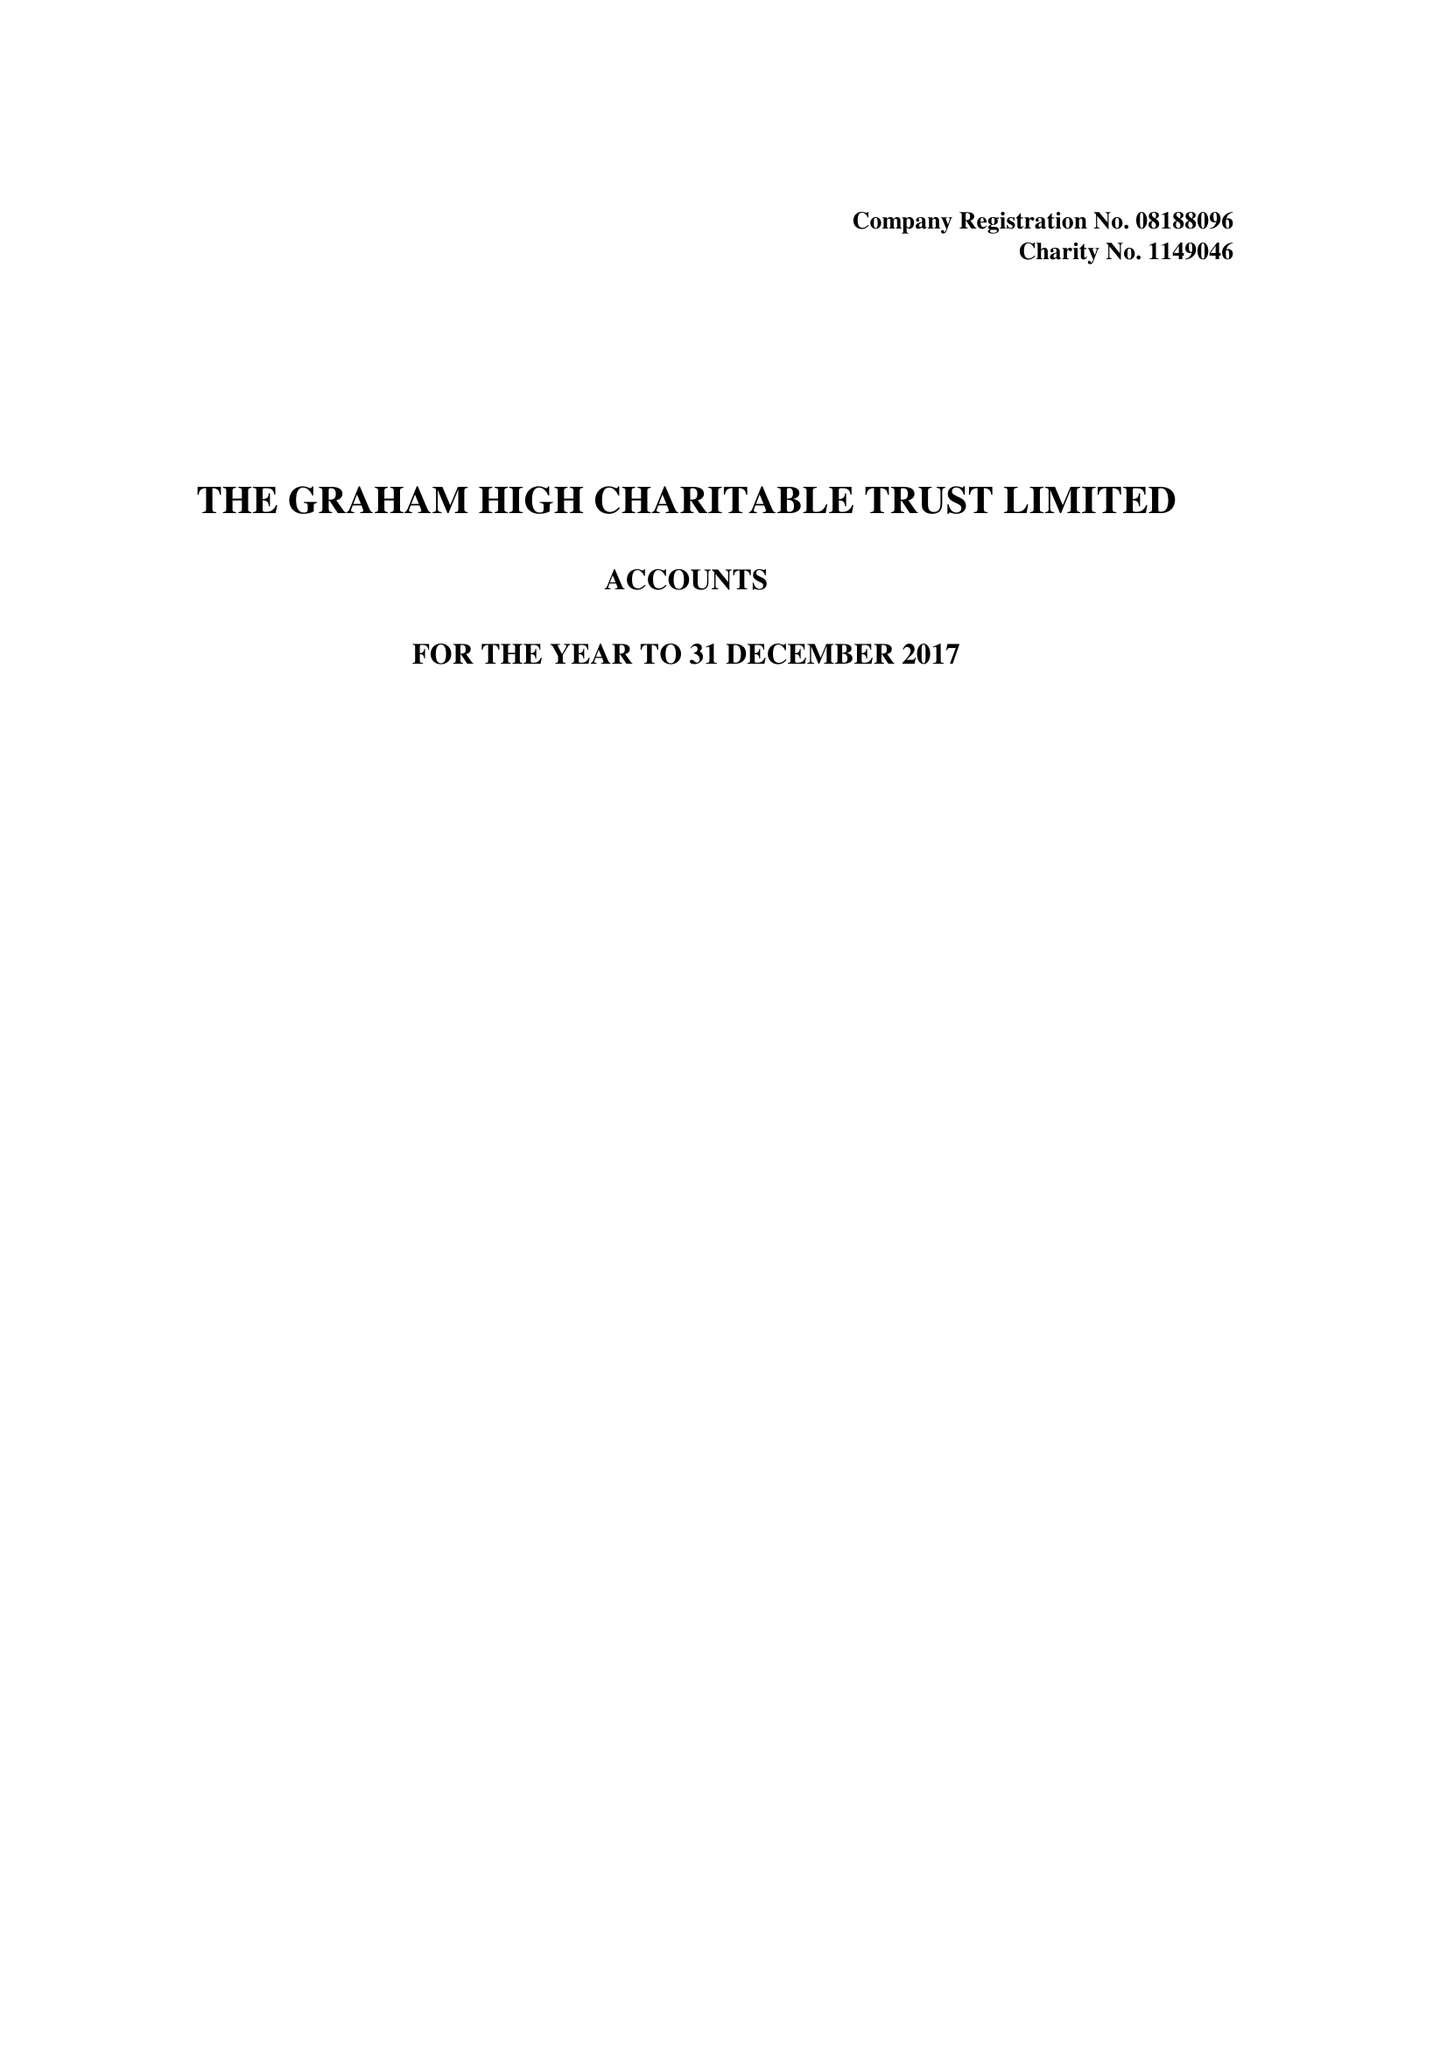What is the value for the report_date?
Answer the question using a single word or phrase. 2017-12-31 